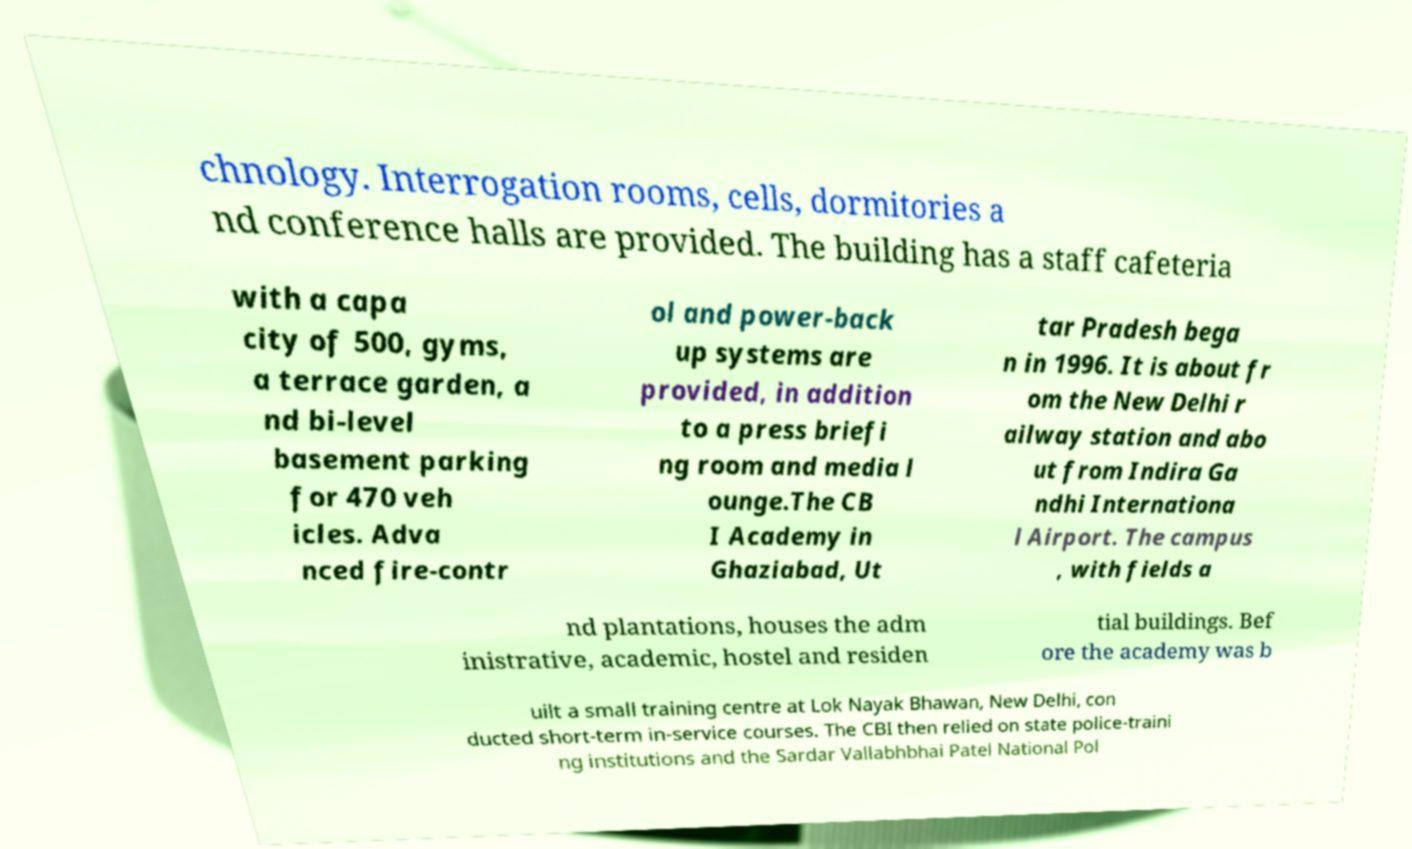Please read and relay the text visible in this image. What does it say? chnology. Interrogation rooms, cells, dormitories a nd conference halls are provided. The building has a staff cafeteria with a capa city of 500, gyms, a terrace garden, a nd bi-level basement parking for 470 veh icles. Adva nced fire-contr ol and power-back up systems are provided, in addition to a press briefi ng room and media l ounge.The CB I Academy in Ghaziabad, Ut tar Pradesh bega n in 1996. It is about fr om the New Delhi r ailway station and abo ut from Indira Ga ndhi Internationa l Airport. The campus , with fields a nd plantations, houses the adm inistrative, academic, hostel and residen tial buildings. Bef ore the academy was b uilt a small training centre at Lok Nayak Bhawan, New Delhi, con ducted short-term in-service courses. The CBI then relied on state police-traini ng institutions and the Sardar Vallabhbhai Patel National Pol 